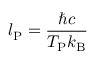Convert formula to latex. <formula><loc_0><loc_0><loc_500><loc_500>l _ { P } = { \frac { \hbar { c } } { T _ { P } k _ { B } } }</formula> 